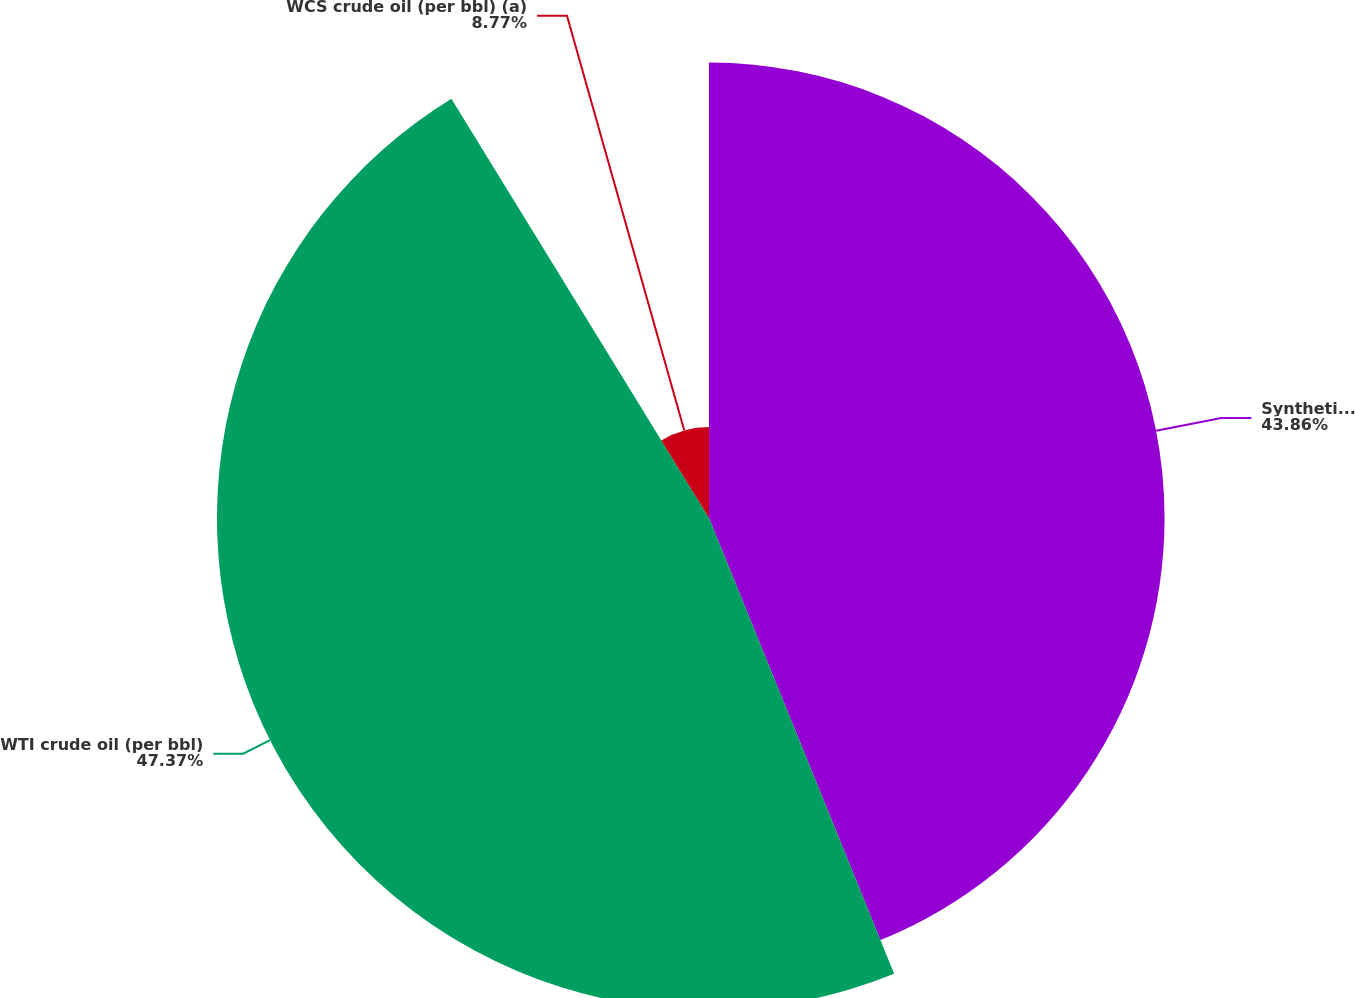Convert chart. <chart><loc_0><loc_0><loc_500><loc_500><pie_chart><fcel>Synthetic Crude Oil (per bbl)<fcel>WTI crude oil (per bbl)<fcel>WCS crude oil (per bbl) (a)<nl><fcel>43.86%<fcel>47.37%<fcel>8.77%<nl></chart> 